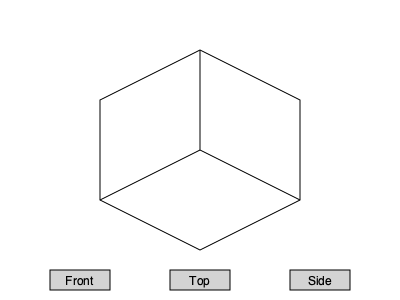Given the isometric view of a cube with an internal diagonal, which of the following statements about its orthographic projections is correct?

A) The front view shows a square with a diagonal line
B) The top view shows a square with no internal lines
C) The side view shows a rectangle with a vertical line
D) All projections show the internal diagonal Let's analyze this step-by-step:

1) First, we need to understand what an isometric view is. It's a method of visually representing 3D objects in 2D, where the three coordinate axes appear equally foreshortened.

2) In the given isometric view, we see a cube with an internal diagonal line connecting two opposite vertices.

3) Now, let's consider each orthographic projection:

   a) Front view: This would be a square, as we're looking directly at one face of the cube. The internal diagonal would not be visible from this angle, as it's inside the cube.

   b) Top view: This would also be a square, representing the top face of the cube. The internal diagonal would not be visible from this angle either.

   c) Side view: This would be a square as well, representing the side face of the cube. The internal diagonal would appear as a straight line from corner to corner in this view.

4) Based on this analysis, we can eliminate options A and D immediately, as the front view won't show the diagonal, and not all projections will show the internal diagonal.

5) Option B is correct for the top view, but it's not the complete answer as it doesn't address the other projections.

6) Option C is incorrect because while the side view does show a line, it would be diagonal, not vertical, and the shape would be a square, not a rectangle.

Therefore, the correct answer is B: The top view shows a square with no internal lines. This is the only statement among the options that is entirely accurate.
Answer: B 